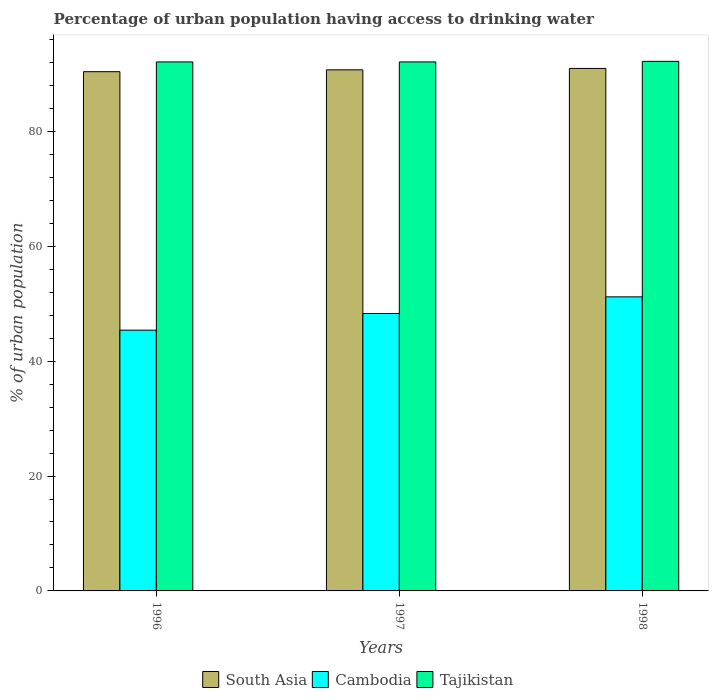How many different coloured bars are there?
Offer a terse response. 3. How many bars are there on the 3rd tick from the left?
Keep it short and to the point. 3. How many bars are there on the 1st tick from the right?
Give a very brief answer. 3. What is the label of the 3rd group of bars from the left?
Provide a short and direct response. 1998. In how many cases, is the number of bars for a given year not equal to the number of legend labels?
Make the answer very short. 0. What is the percentage of urban population having access to drinking water in Cambodia in 1998?
Offer a very short reply. 51.2. Across all years, what is the maximum percentage of urban population having access to drinking water in Cambodia?
Your answer should be very brief. 51.2. Across all years, what is the minimum percentage of urban population having access to drinking water in South Asia?
Offer a terse response. 90.4. What is the total percentage of urban population having access to drinking water in South Asia in the graph?
Your response must be concise. 272.09. What is the difference between the percentage of urban population having access to drinking water in Cambodia in 1996 and that in 1998?
Your answer should be compact. -5.8. What is the difference between the percentage of urban population having access to drinking water in Cambodia in 1998 and the percentage of urban population having access to drinking water in South Asia in 1996?
Your response must be concise. -39.2. What is the average percentage of urban population having access to drinking water in Cambodia per year?
Give a very brief answer. 48.3. In the year 1997, what is the difference between the percentage of urban population having access to drinking water in Cambodia and percentage of urban population having access to drinking water in South Asia?
Keep it short and to the point. -42.42. In how many years, is the percentage of urban population having access to drinking water in Cambodia greater than 32 %?
Your answer should be compact. 3. What is the ratio of the percentage of urban population having access to drinking water in Tajikistan in 1996 to that in 1998?
Offer a very short reply. 1. Is the percentage of urban population having access to drinking water in South Asia in 1997 less than that in 1998?
Offer a terse response. Yes. Is the difference between the percentage of urban population having access to drinking water in Cambodia in 1996 and 1997 greater than the difference between the percentage of urban population having access to drinking water in South Asia in 1996 and 1997?
Your answer should be compact. No. What is the difference between the highest and the second highest percentage of urban population having access to drinking water in South Asia?
Your answer should be compact. 0.25. What is the difference between the highest and the lowest percentage of urban population having access to drinking water in Cambodia?
Your response must be concise. 5.8. In how many years, is the percentage of urban population having access to drinking water in Cambodia greater than the average percentage of urban population having access to drinking water in Cambodia taken over all years?
Provide a succinct answer. 2. What does the 2nd bar from the left in 1996 represents?
Offer a terse response. Cambodia. What does the 2nd bar from the right in 1997 represents?
Your answer should be very brief. Cambodia. Is it the case that in every year, the sum of the percentage of urban population having access to drinking water in South Asia and percentage of urban population having access to drinking water in Cambodia is greater than the percentage of urban population having access to drinking water in Tajikistan?
Provide a short and direct response. Yes. Are the values on the major ticks of Y-axis written in scientific E-notation?
Make the answer very short. No. Does the graph contain any zero values?
Keep it short and to the point. No. Does the graph contain grids?
Give a very brief answer. No. How many legend labels are there?
Offer a terse response. 3. What is the title of the graph?
Give a very brief answer. Percentage of urban population having access to drinking water. Does "East Asia (developing only)" appear as one of the legend labels in the graph?
Ensure brevity in your answer.  No. What is the label or title of the X-axis?
Offer a very short reply. Years. What is the label or title of the Y-axis?
Your answer should be very brief. % of urban population. What is the % of urban population of South Asia in 1996?
Make the answer very short. 90.4. What is the % of urban population in Cambodia in 1996?
Make the answer very short. 45.4. What is the % of urban population of Tajikistan in 1996?
Provide a short and direct response. 92.1. What is the % of urban population of South Asia in 1997?
Provide a succinct answer. 90.72. What is the % of urban population of Cambodia in 1997?
Keep it short and to the point. 48.3. What is the % of urban population of Tajikistan in 1997?
Keep it short and to the point. 92.1. What is the % of urban population of South Asia in 1998?
Your answer should be compact. 90.97. What is the % of urban population of Cambodia in 1998?
Give a very brief answer. 51.2. What is the % of urban population in Tajikistan in 1998?
Keep it short and to the point. 92.2. Across all years, what is the maximum % of urban population in South Asia?
Offer a terse response. 90.97. Across all years, what is the maximum % of urban population in Cambodia?
Give a very brief answer. 51.2. Across all years, what is the maximum % of urban population of Tajikistan?
Your answer should be very brief. 92.2. Across all years, what is the minimum % of urban population in South Asia?
Your answer should be very brief. 90.4. Across all years, what is the minimum % of urban population in Cambodia?
Offer a very short reply. 45.4. Across all years, what is the minimum % of urban population in Tajikistan?
Your answer should be compact. 92.1. What is the total % of urban population of South Asia in the graph?
Keep it short and to the point. 272.09. What is the total % of urban population in Cambodia in the graph?
Make the answer very short. 144.9. What is the total % of urban population in Tajikistan in the graph?
Provide a succinct answer. 276.4. What is the difference between the % of urban population of South Asia in 1996 and that in 1997?
Your answer should be very brief. -0.32. What is the difference between the % of urban population in Cambodia in 1996 and that in 1997?
Your response must be concise. -2.9. What is the difference between the % of urban population of South Asia in 1996 and that in 1998?
Provide a succinct answer. -0.57. What is the difference between the % of urban population of Cambodia in 1996 and that in 1998?
Give a very brief answer. -5.8. What is the difference between the % of urban population in South Asia in 1997 and that in 1998?
Your answer should be very brief. -0.25. What is the difference between the % of urban population in South Asia in 1996 and the % of urban population in Cambodia in 1997?
Provide a succinct answer. 42.1. What is the difference between the % of urban population of South Asia in 1996 and the % of urban population of Tajikistan in 1997?
Provide a succinct answer. -1.7. What is the difference between the % of urban population of Cambodia in 1996 and the % of urban population of Tajikistan in 1997?
Keep it short and to the point. -46.7. What is the difference between the % of urban population in South Asia in 1996 and the % of urban population in Cambodia in 1998?
Offer a terse response. 39.2. What is the difference between the % of urban population of South Asia in 1996 and the % of urban population of Tajikistan in 1998?
Keep it short and to the point. -1.8. What is the difference between the % of urban population of Cambodia in 1996 and the % of urban population of Tajikistan in 1998?
Your answer should be very brief. -46.8. What is the difference between the % of urban population in South Asia in 1997 and the % of urban population in Cambodia in 1998?
Offer a very short reply. 39.52. What is the difference between the % of urban population of South Asia in 1997 and the % of urban population of Tajikistan in 1998?
Offer a terse response. -1.48. What is the difference between the % of urban population of Cambodia in 1997 and the % of urban population of Tajikistan in 1998?
Your answer should be very brief. -43.9. What is the average % of urban population of South Asia per year?
Provide a short and direct response. 90.7. What is the average % of urban population of Cambodia per year?
Your answer should be very brief. 48.3. What is the average % of urban population in Tajikistan per year?
Your response must be concise. 92.13. In the year 1996, what is the difference between the % of urban population of South Asia and % of urban population of Cambodia?
Offer a terse response. 45. In the year 1996, what is the difference between the % of urban population of South Asia and % of urban population of Tajikistan?
Your answer should be compact. -1.7. In the year 1996, what is the difference between the % of urban population of Cambodia and % of urban population of Tajikistan?
Provide a short and direct response. -46.7. In the year 1997, what is the difference between the % of urban population of South Asia and % of urban population of Cambodia?
Offer a terse response. 42.42. In the year 1997, what is the difference between the % of urban population in South Asia and % of urban population in Tajikistan?
Your answer should be compact. -1.38. In the year 1997, what is the difference between the % of urban population in Cambodia and % of urban population in Tajikistan?
Your response must be concise. -43.8. In the year 1998, what is the difference between the % of urban population of South Asia and % of urban population of Cambodia?
Offer a terse response. 39.77. In the year 1998, what is the difference between the % of urban population in South Asia and % of urban population in Tajikistan?
Ensure brevity in your answer.  -1.23. In the year 1998, what is the difference between the % of urban population in Cambodia and % of urban population in Tajikistan?
Your answer should be very brief. -41. What is the ratio of the % of urban population of South Asia in 1996 to that in 1997?
Keep it short and to the point. 1. What is the ratio of the % of urban population in Cambodia in 1996 to that in 1997?
Offer a very short reply. 0.94. What is the ratio of the % of urban population in Cambodia in 1996 to that in 1998?
Make the answer very short. 0.89. What is the ratio of the % of urban population in Tajikistan in 1996 to that in 1998?
Give a very brief answer. 1. What is the ratio of the % of urban population in Cambodia in 1997 to that in 1998?
Offer a terse response. 0.94. What is the ratio of the % of urban population in Tajikistan in 1997 to that in 1998?
Offer a terse response. 1. What is the difference between the highest and the second highest % of urban population of South Asia?
Provide a short and direct response. 0.25. What is the difference between the highest and the lowest % of urban population in South Asia?
Provide a short and direct response. 0.57. 